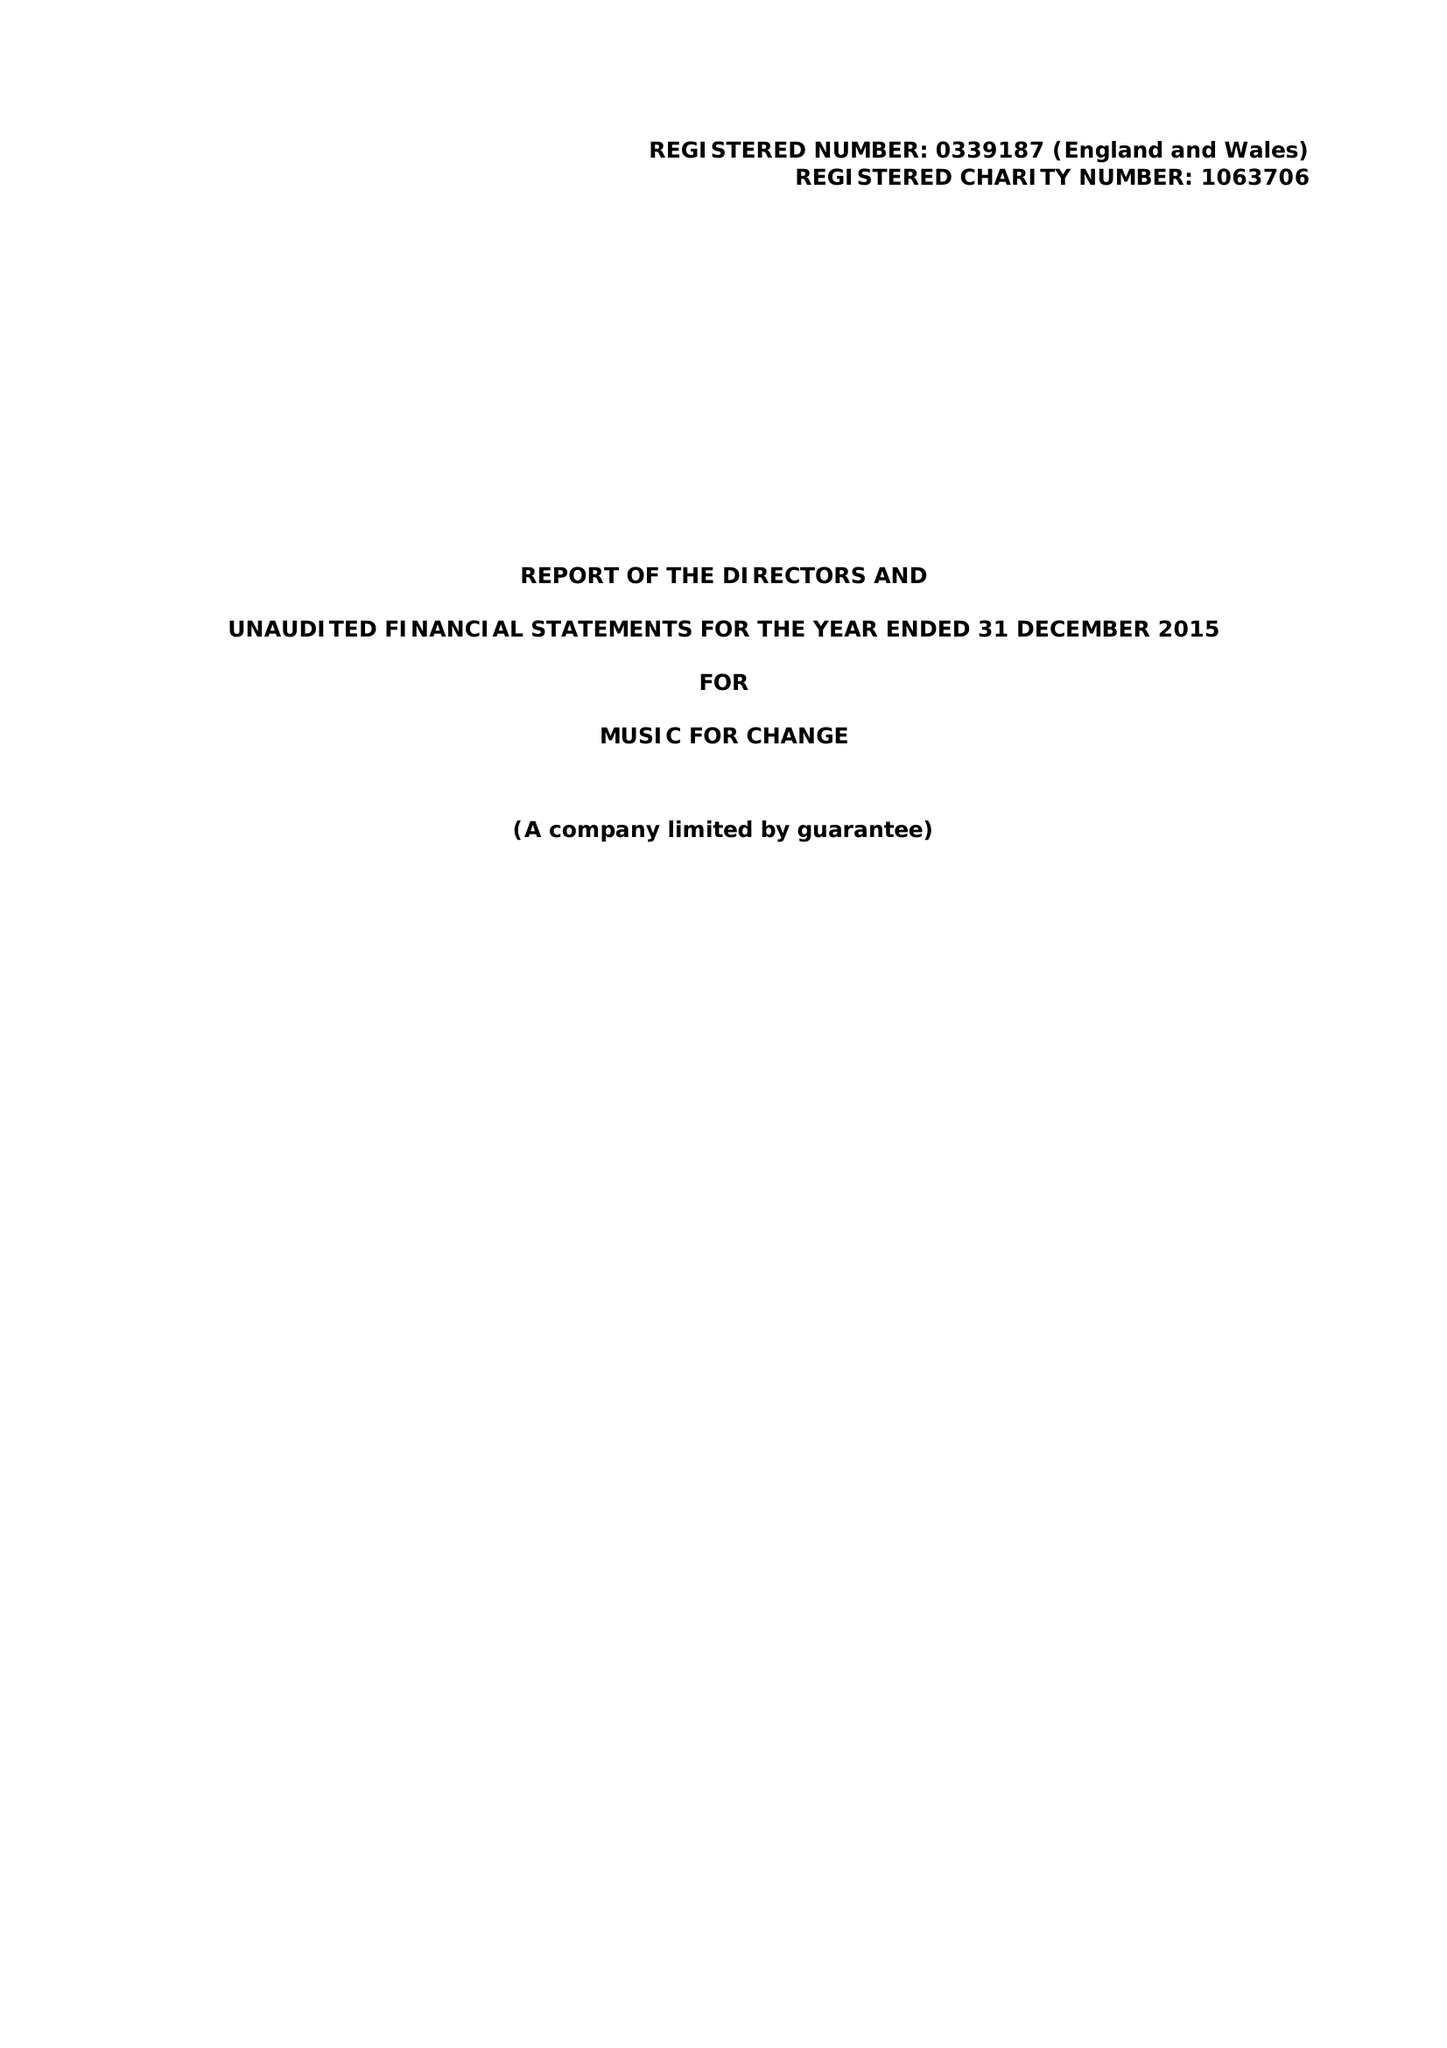What is the value for the charity_number?
Answer the question using a single word or phrase. 1063706 